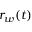Convert formula to latex. <formula><loc_0><loc_0><loc_500><loc_500>r _ { w } ( t )</formula> 